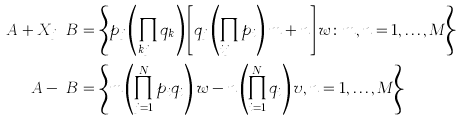Convert formula to latex. <formula><loc_0><loc_0><loc_500><loc_500>\ A + X _ { j } \ B & = \left \{ p _ { j } \left ( \prod _ { k \neq j } q _ { k } \right ) \left [ q _ { j } \left ( \prod _ { i \neq j } p _ { i } \right ) m + n \right ] w \colon m , n = 1 , \dots , M \right \} \\ \ A - \ B & = \left \{ m \left ( \prod _ { j = 1 } ^ { N } p _ { i } q _ { i } \right ) w - n \left ( \prod _ { i = 1 } ^ { N } q _ { i } \right ) v , n = 1 , \dots , M \right \}</formula> 